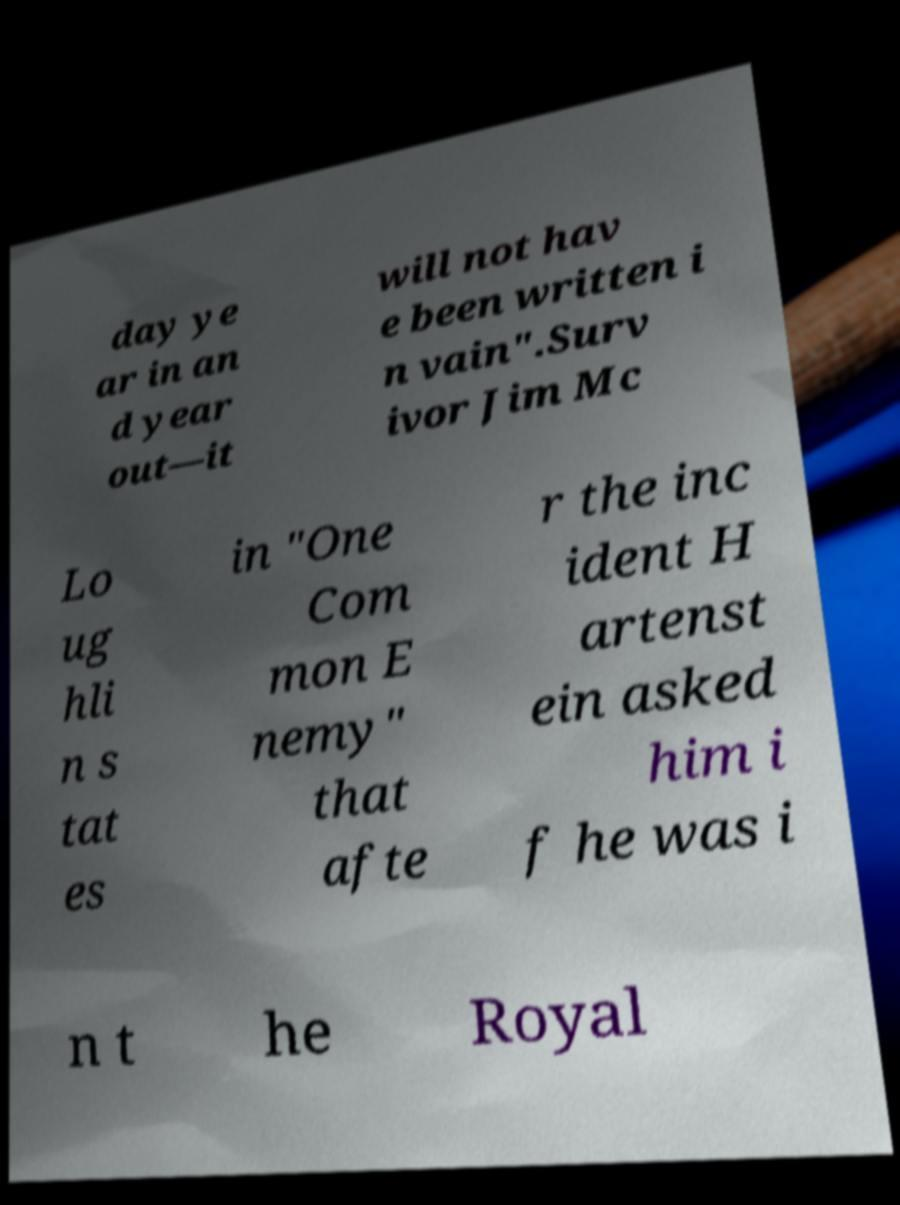Can you accurately transcribe the text from the provided image for me? day ye ar in an d year out—it will not hav e been written i n vain".Surv ivor Jim Mc Lo ug hli n s tat es in "One Com mon E nemy" that afte r the inc ident H artenst ein asked him i f he was i n t he Royal 